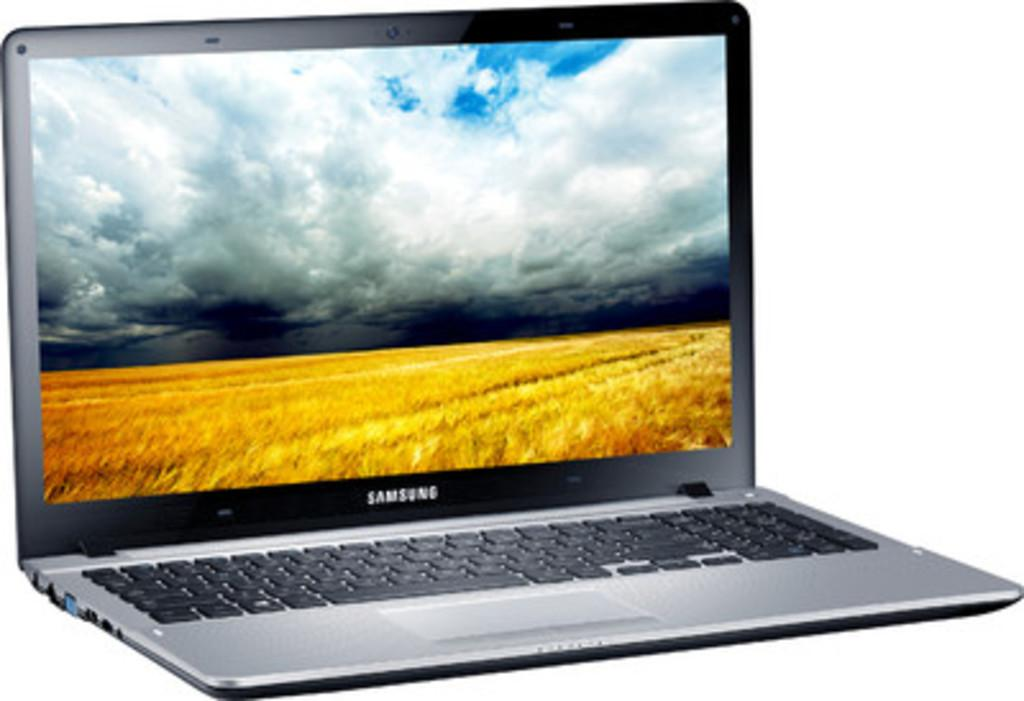<image>
Offer a succinct explanation of the picture presented. A samsung laptop with a picture of a field 